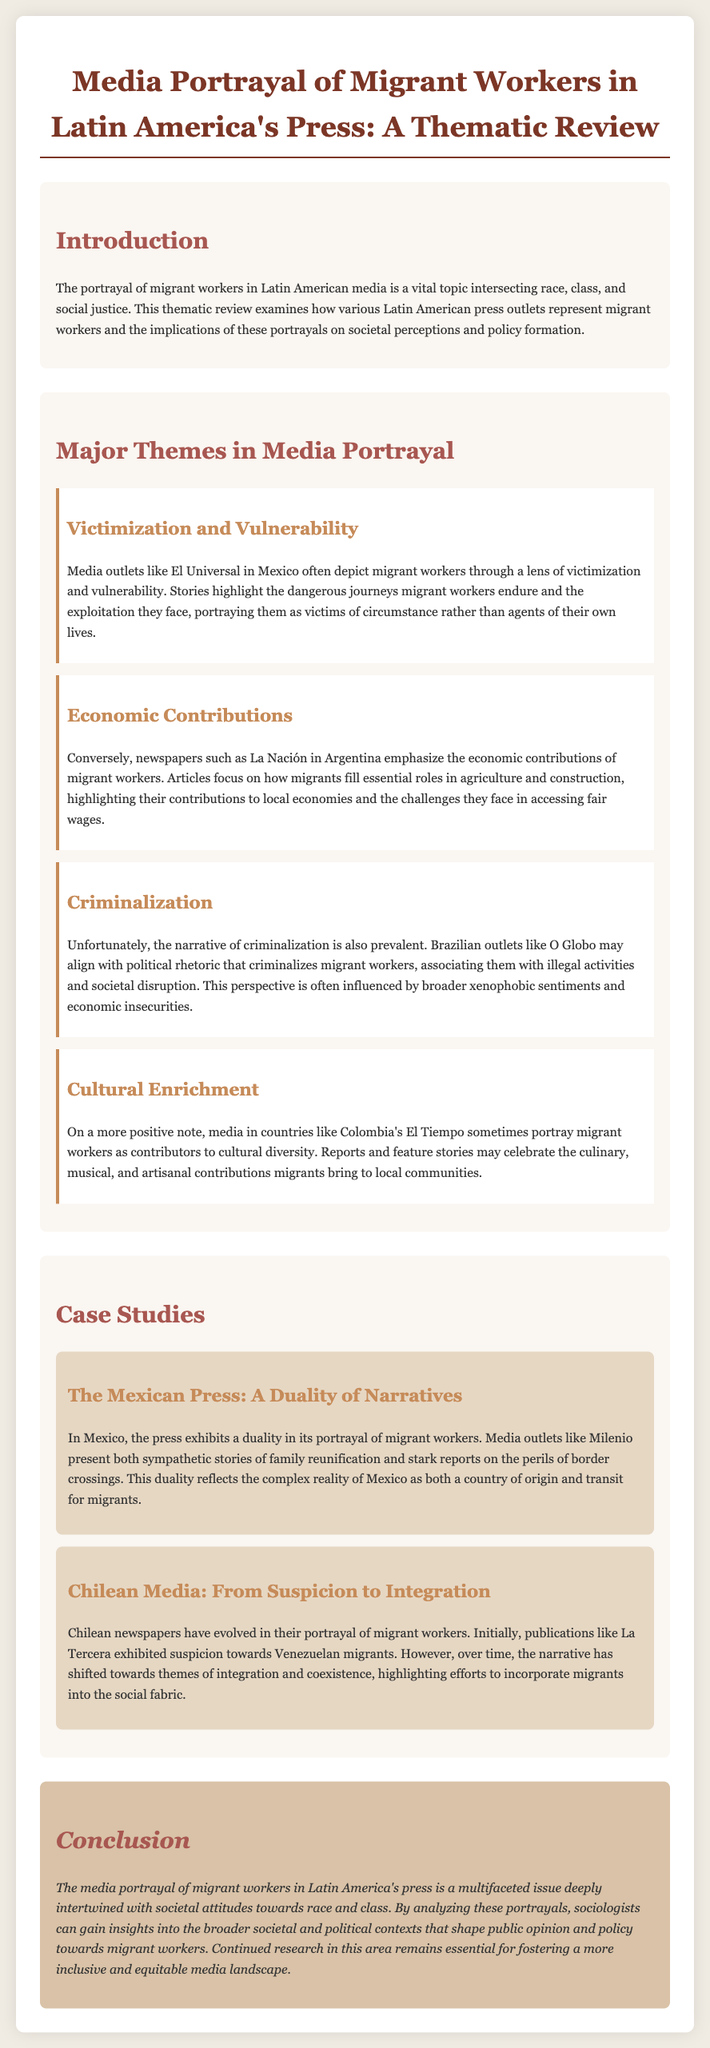what is the title of the document? The title is indicated at the top of the document and summarizes its focus, which is on media portrayal.
Answer: Media Portrayal of Migrant Workers in Latin America's Press: A Thematic Review which press outlet in Mexico is mentioned for victimization portrayal? The document lists specific media outlets that represent migrant workers, identifying one for victim narratives.
Answer: El Universal which theme emphasizes the economic roles of migrants? The themes are divided into specific categories, one of which highlights the contributions of migrants to the economy.
Answer: Economic Contributions what case study discusses Chilean media's portrayal of migrant workers? The case studies provide examples of media portrayal evolution in specific countries, including one for Chile.
Answer: Chilean Media: From Suspicion to Integration name a country where migrants are portrayed as culturally enriching. The document addresses how certain countries view the contributions of migrant workers, mentioning a specific media outlet.
Answer: Colombia's El Tiempo what is one effect of the media portrayal of migrant workers? The document suggests a broader implication of how media representations influence societal attitudes and policy.
Answer: Insight into societal attitudes how many case studies are presented in the document? The case studies are clearly delineated in the document, providing specific examples of media narratives.
Answer: Two what narrative does the Brazilian outlet O Globo align with? The document indicates a particular perspective that Brazilian media outlets may reflect regarding migrant workers.
Answer: Criminalization 